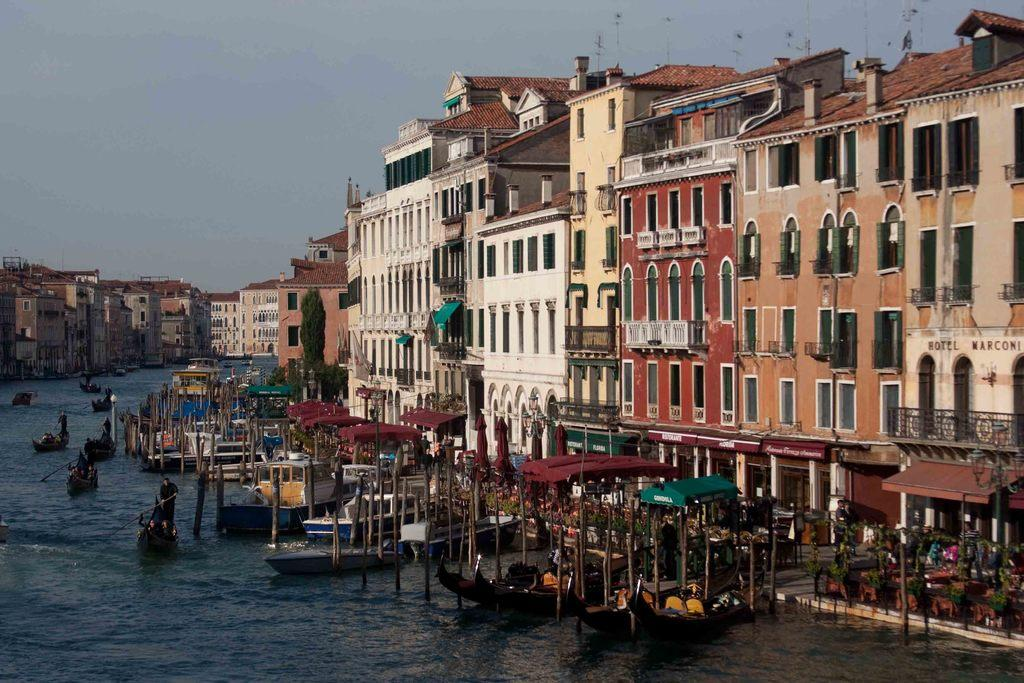What can be seen on the right side of the image? On the right side of the image, there are many boats, people, buildings, and trees. What is visible on the left side of the image? On the left side of the image, there are boats, people, water, waves, buildings, and the sky. Can you describe the water on the left side of the image? The water on the left side of the image has visible waves. What can be seen in the sky in the image? The sky is visible in the image. How does the growth of the trees affect the engine of the boats in the image? There is no mention of growth or engine in the image, as it primarily features boats, people, buildings, trees, and water. 